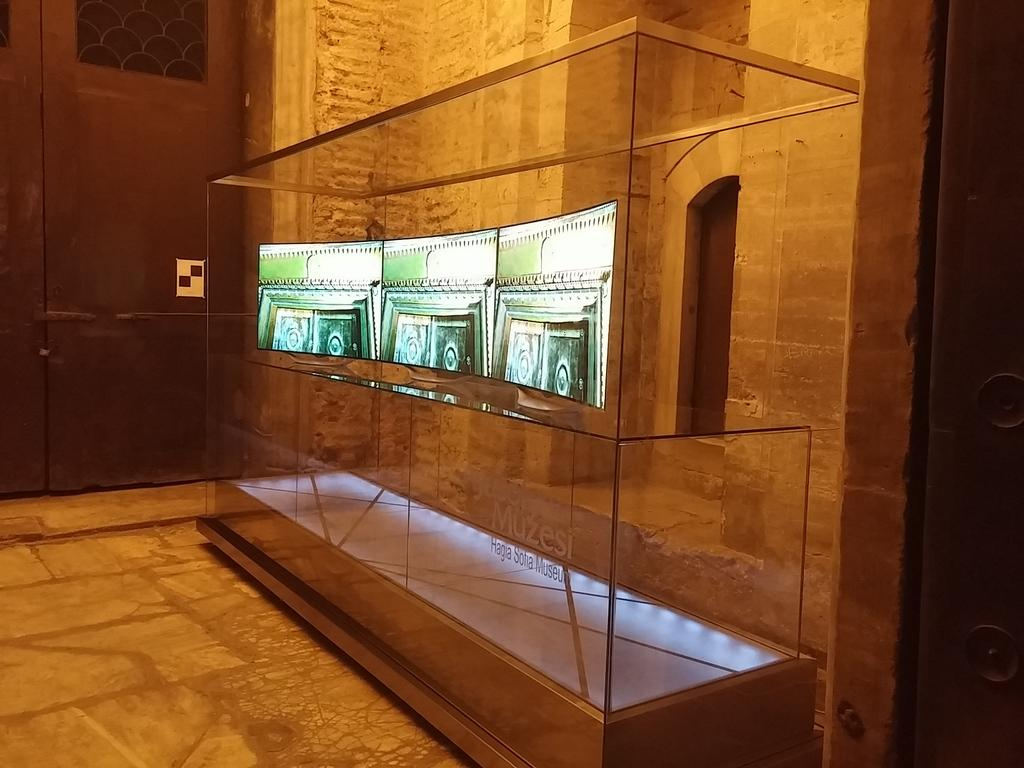What type of object with a screen and text can be seen in the image? There is a glass object with a screen and text in the image. What is visible beneath the object? The ground is visible in the image. What is attached to the wall in the image? There is an object on the wall in the image. Are there any openings in the image? Yes, there are doors in the image. What type of seed is being used to light up the object on the wall in the image? There is no seed or flame present in the image; it features a glass object with a screen and text, a wall with an object, and doors. 